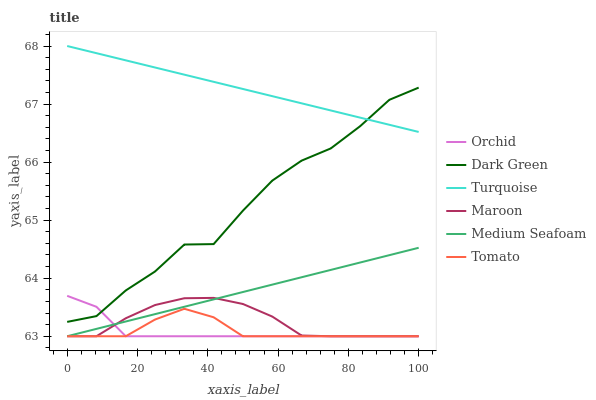Does Orchid have the minimum area under the curve?
Answer yes or no. Yes. Does Turquoise have the maximum area under the curve?
Answer yes or no. Yes. Does Maroon have the minimum area under the curve?
Answer yes or no. No. Does Maroon have the maximum area under the curve?
Answer yes or no. No. Is Medium Seafoam the smoothest?
Answer yes or no. Yes. Is Dark Green the roughest?
Answer yes or no. Yes. Is Turquoise the smoothest?
Answer yes or no. No. Is Turquoise the roughest?
Answer yes or no. No. Does Tomato have the lowest value?
Answer yes or no. Yes. Does Turquoise have the lowest value?
Answer yes or no. No. Does Turquoise have the highest value?
Answer yes or no. Yes. Does Maroon have the highest value?
Answer yes or no. No. Is Tomato less than Turquoise?
Answer yes or no. Yes. Is Turquoise greater than Tomato?
Answer yes or no. Yes. Does Orchid intersect Maroon?
Answer yes or no. Yes. Is Orchid less than Maroon?
Answer yes or no. No. Is Orchid greater than Maroon?
Answer yes or no. No. Does Tomato intersect Turquoise?
Answer yes or no. No. 